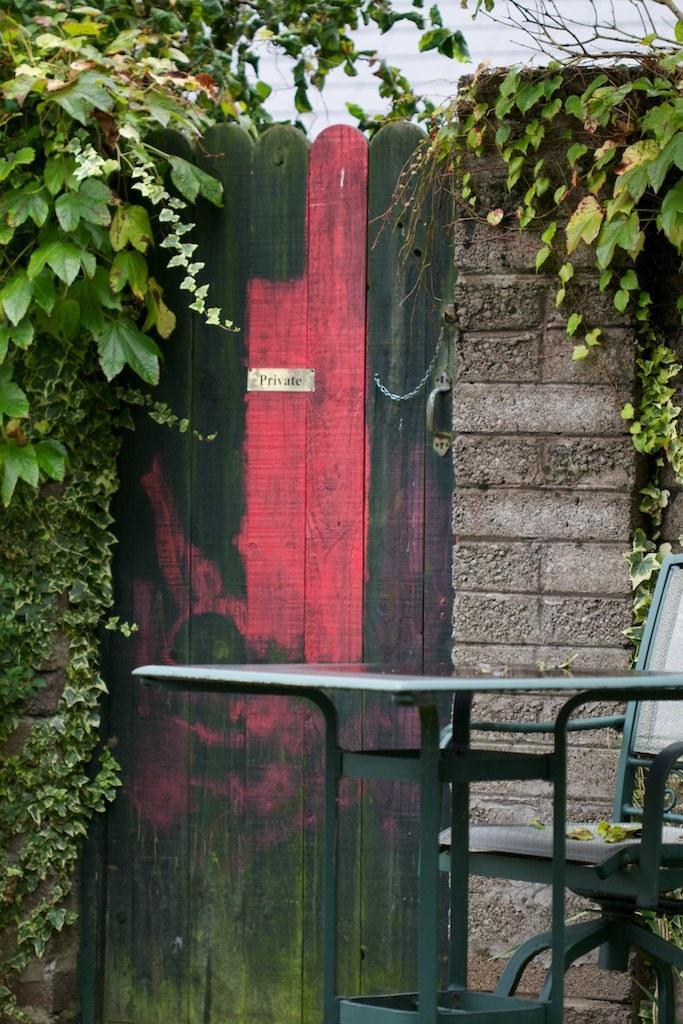Describe this image in one or two sentences. In this picture we can see a door, chain and a door handle. There are few plants on the left and right side of the image. A chair and a table is visible on the right side. 